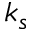<formula> <loc_0><loc_0><loc_500><loc_500>k _ { s }</formula> 